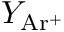<formula> <loc_0><loc_0><loc_500><loc_500>Y _ { A r ^ { + } }</formula> 